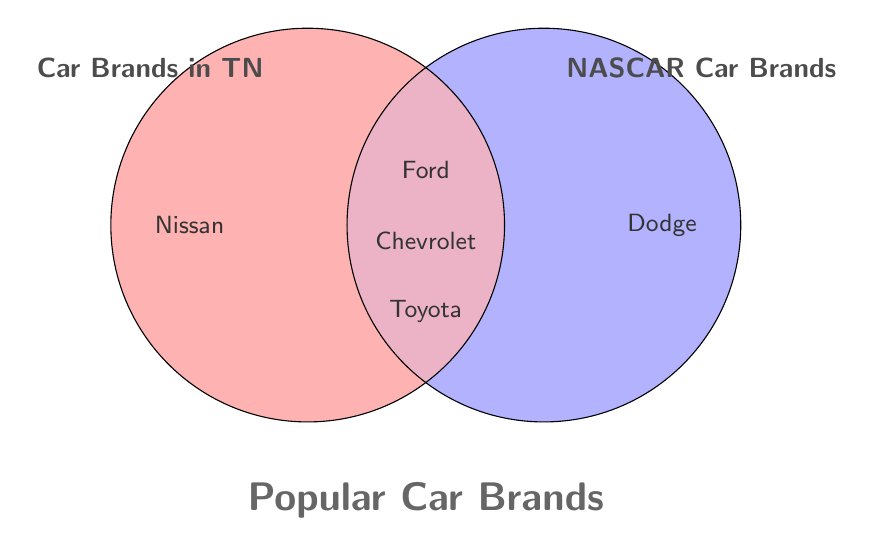Which car brands are popular in Tennessee but not in NASCAR? The left part of the Venn Diagram represents brands popular in Tennessee but not in NASCAR. These brands are not in the overlapping area.
Answer: Nissan Which car brands are present in both Tennessee and NASCAR? The middle overlapping section of the Venn Diagram represents brands that are present in both Tennessee and NASCAR.
Answer: Ford, Chevrolet, Toyota How many car brands are unique to NASCAR? The right part of the Venn Diagram represents brands unique to NASCAR. These brands are not in the overlapping area.
Answer: 1 Which car brands are only popular in Tennessee and not in NASCAR? Look at the left circle excluding the overlap portion to find the brands exclusive to Tennessee.
Answer: Nissan Are there any brands listed in the figure that are neither popular in Tennessee nor in NASCAR? The Venn Diagram only shows car brands relevant to either or both categories. No brands fall outside the two circles.
Answer: No brands outside How many total car brands are shown in the diagram? Count all brands shown in both the circles and overlap.
Answer: 5 Which area has more car brands: only in NASCAR or only in Tennessee? Compare the count of brands exclusive to the circles. Only in Tennessee is 1, only in NASCAR is 1.
Answer: Both are equal Which car brands appear in the red-shaded part of the Venn Diagram? The red-shaded part represents Car Brands in Tennessee. Look within this section and overlap.
Answer: Ford, Chevrolet, Toyota, Nissan How many car brands are shown in both the red and blue-shaded parts of the Venn Diagram? Count the number of brands in the overlapping purple area.
Answer: 3 Which car brands are unique to the blue-shaded part of the Venn Diagram? The blue-shaded part represents NASCAR Car Brands. Look within this section excluding overlap.
Answer: Dodge 